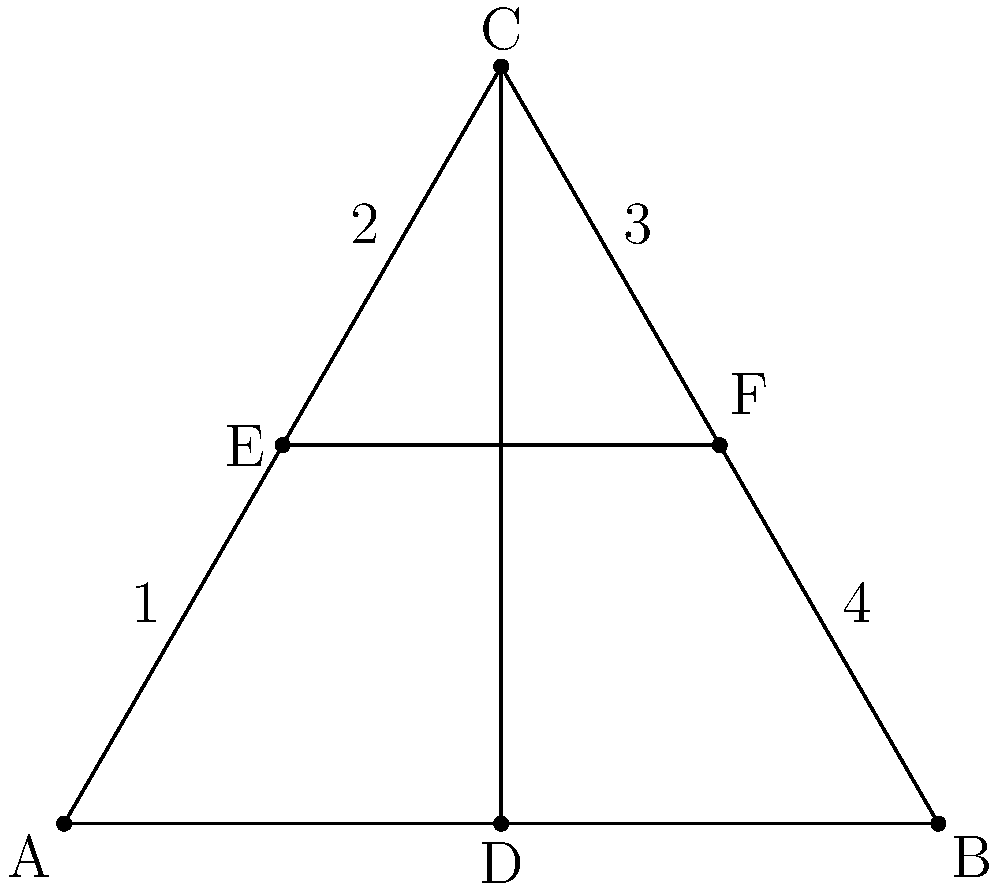In the given equilateral triangle ABC with inscribed cross, what is the ratio of the area of region 1 to the total area of the triangle? How does this relate to the symmetry of religious symbols in geometric shapes? To solve this problem, let's follow these steps:

1) First, we need to recognize that the triangle is divided into 6 equal parts by the inscribed cross. This is because:
   a) The vertical line CD bisects the base AB, creating two equal triangles.
   b) The horizontal line EF is parallel to AB and passes through the midpoint of CD, thus dividing each half of the triangle into three equal parts.

2) The area of region 1 is one of these six equal parts.

3) Therefore, the ratio of the area of region 1 to the total area of the triangle is 1:6 or $\frac{1}{6}$.

4) This relates to the symmetry of religious symbols in geometric shapes in several ways:
   a) The cross inscribed in the triangle creates perfect symmetry, dividing the triangle into six equal parts. This symmetry is often found in religious symbols, representing balance and harmony.
   b) The equilateral triangle itself is a symbol of the Holy Trinity in Christianity, with its three equal sides representing the Father, Son, and Holy Spirit.
   c) The intersection of the cross at the center of the triangle could represent the central role of the cross in Christian theology, while still maintaining the integrity of the triangular shape.
   d) The ratio of 1:6 might be interpreted as representing the creation story in some religions, where the world was created in six days, with each part of the triangle representing one day.

5) This geometric representation combines multiple religious symbols (triangle and cross) in a harmonious and proportional way, demonstrating how religious symbols can be integrated into geometric shapes while maintaining both symmetry and symbolic meaning.
Answer: $\frac{1}{6}$ 